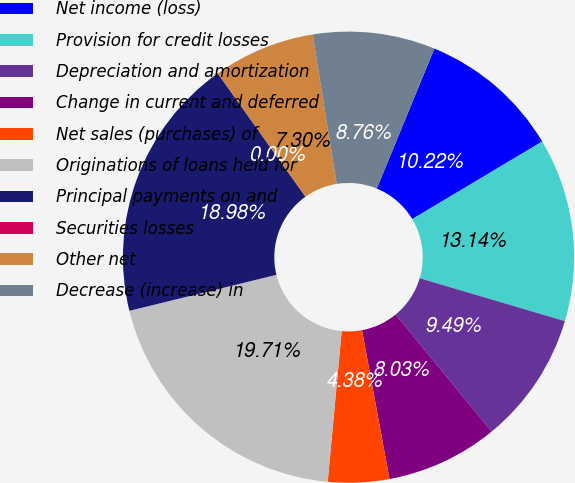Convert chart to OTSL. <chart><loc_0><loc_0><loc_500><loc_500><pie_chart><fcel>Net income (loss)<fcel>Provision for credit losses<fcel>Depreciation and amortization<fcel>Change in current and deferred<fcel>Net sales (purchases) of<fcel>Originations of loans held for<fcel>Principal payments on and<fcel>Securities losses<fcel>Other net<fcel>Decrease (increase) in<nl><fcel>10.22%<fcel>13.14%<fcel>9.49%<fcel>8.03%<fcel>4.38%<fcel>19.71%<fcel>18.98%<fcel>0.0%<fcel>7.3%<fcel>8.76%<nl></chart> 